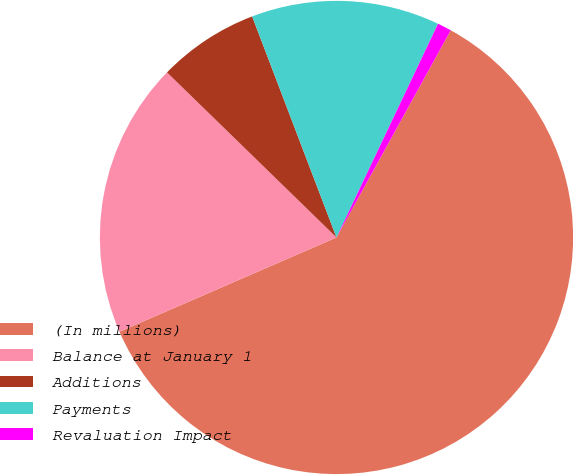Convert chart. <chart><loc_0><loc_0><loc_500><loc_500><pie_chart><fcel>(In millions)<fcel>Balance at January 1<fcel>Additions<fcel>Payments<fcel>Revaluation Impact<nl><fcel>60.46%<fcel>18.81%<fcel>6.91%<fcel>12.86%<fcel>0.96%<nl></chart> 